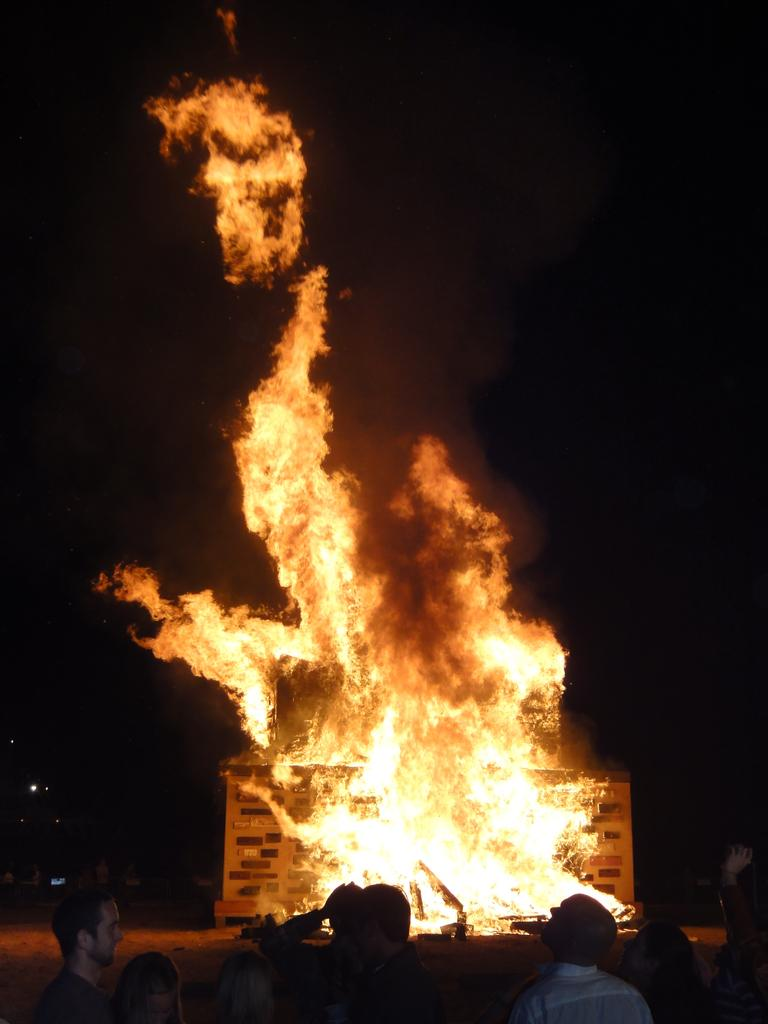What is the main event happening in the image? There is fire in the image, and it appears that a house caught fire. Are there any people present in the image? Yes, there are people standing in the image. What is the color of the background in the image? The background of the image is dark. Can you tell me how much money is being exchanged between the people in the image? There is no indication of money exchange in the image; it focuses on the fire and the people standing nearby. Is there a playground visible in the image? No, there is no playground present in the image. 